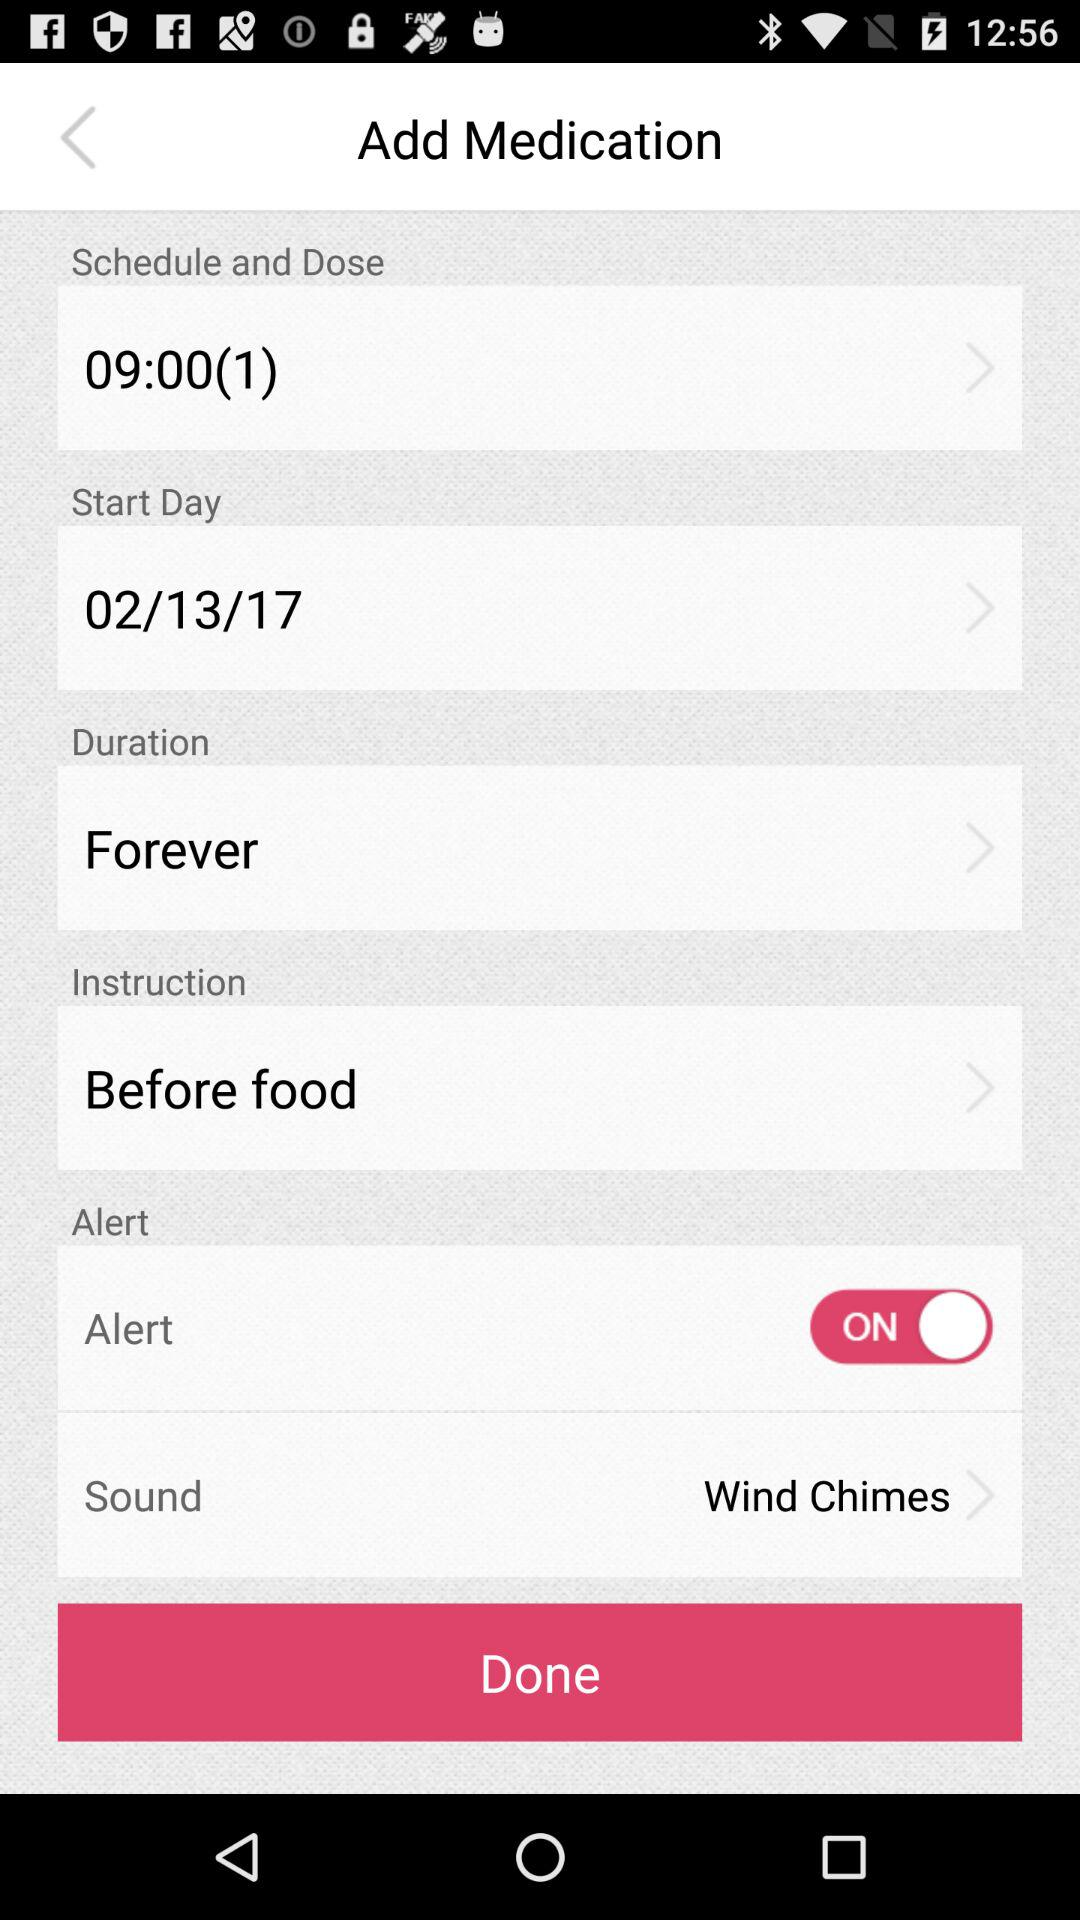What is the scheduled time for the dose? The scheduled time is 09:00. 